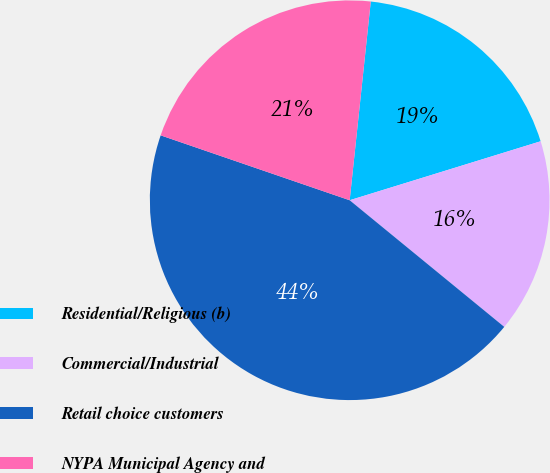Convert chart. <chart><loc_0><loc_0><loc_500><loc_500><pie_chart><fcel>Residential/Religious (b)<fcel>Commercial/Industrial<fcel>Retail choice customers<fcel>NYPA Municipal Agency and<nl><fcel>18.55%<fcel>15.69%<fcel>44.34%<fcel>21.42%<nl></chart> 